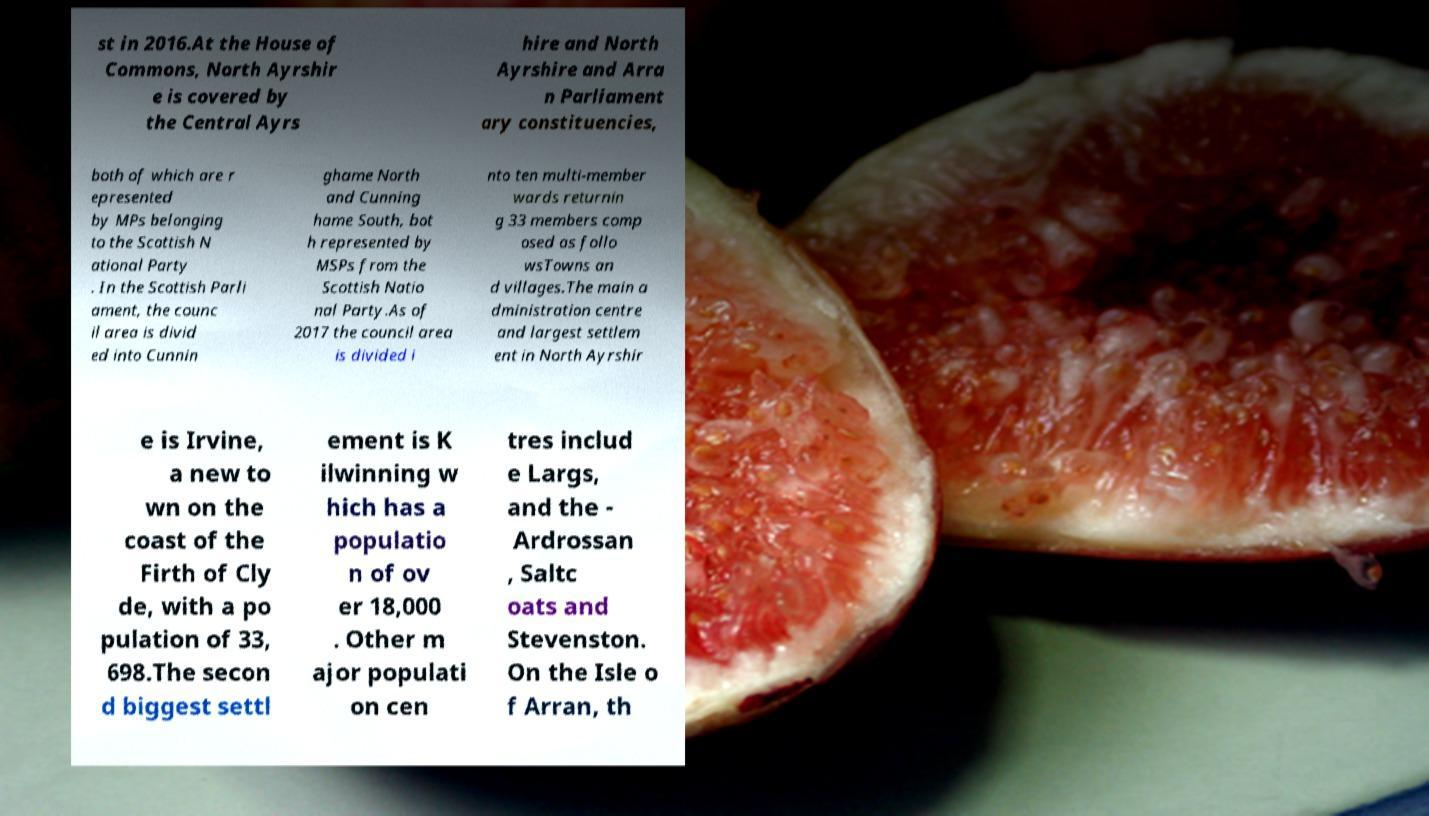Could you assist in decoding the text presented in this image and type it out clearly? st in 2016.At the House of Commons, North Ayrshir e is covered by the Central Ayrs hire and North Ayrshire and Arra n Parliament ary constituencies, both of which are r epresented by MPs belonging to the Scottish N ational Party . In the Scottish Parli ament, the counc il area is divid ed into Cunnin ghame North and Cunning hame South, bot h represented by MSPs from the Scottish Natio nal Party.As of 2017 the council area is divided i nto ten multi-member wards returnin g 33 members comp osed as follo wsTowns an d villages.The main a dministration centre and largest settlem ent in North Ayrshir e is Irvine, a new to wn on the coast of the Firth of Cly de, with a po pulation of 33, 698.The secon d biggest settl ement is K ilwinning w hich has a populatio n of ov er 18,000 . Other m ajor populati on cen tres includ e Largs, and the - Ardrossan , Saltc oats and Stevenston. On the Isle o f Arran, th 